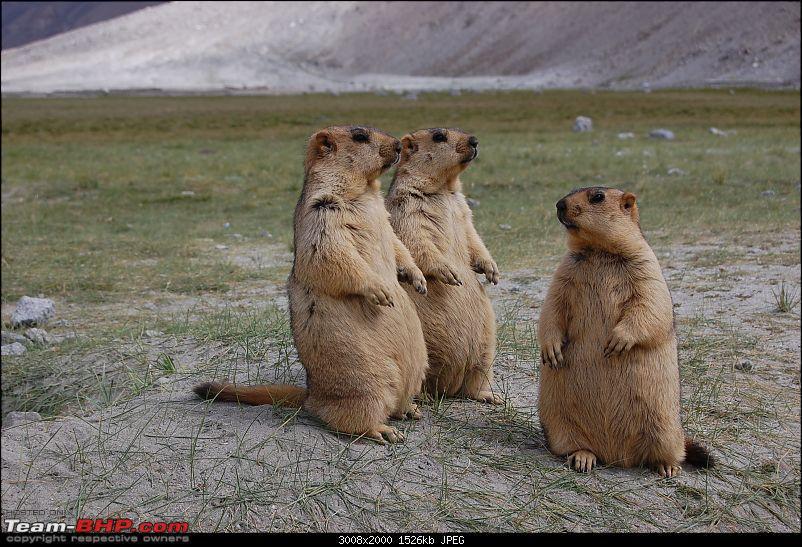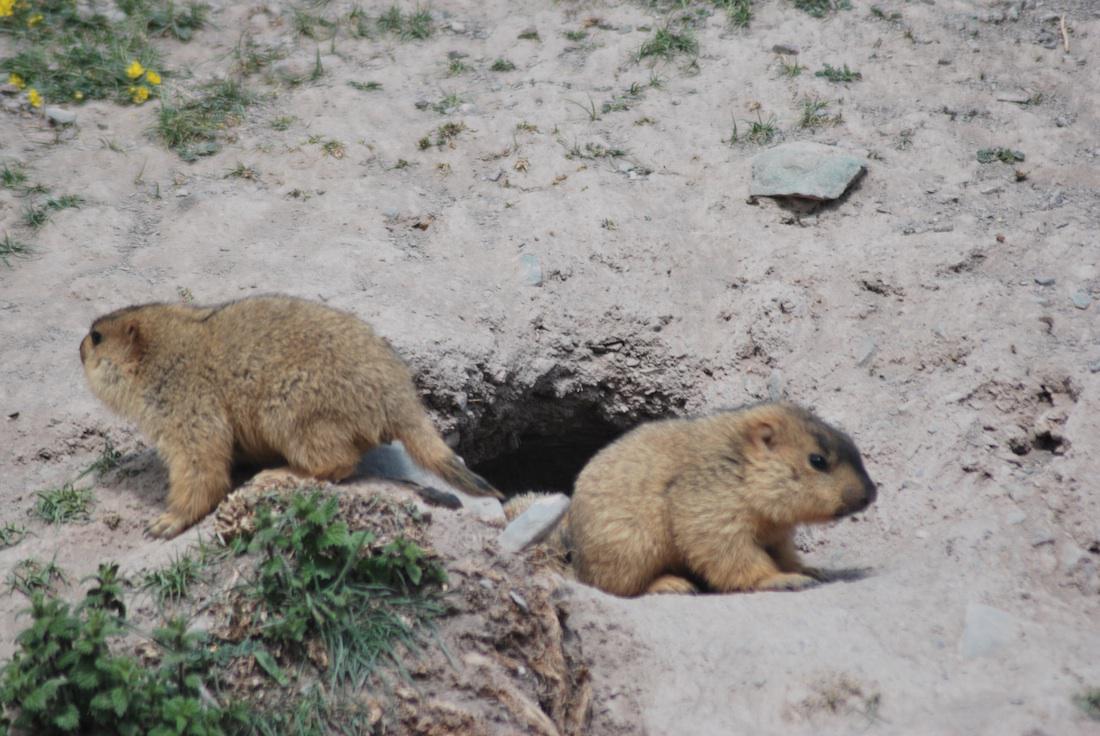The first image is the image on the left, the second image is the image on the right. Given the left and right images, does the statement "There are two marmots touching in the right image." hold true? Answer yes or no. No. The first image is the image on the left, the second image is the image on the right. For the images shown, is this caption "There is a total of three animals in the pair of images." true? Answer yes or no. No. 